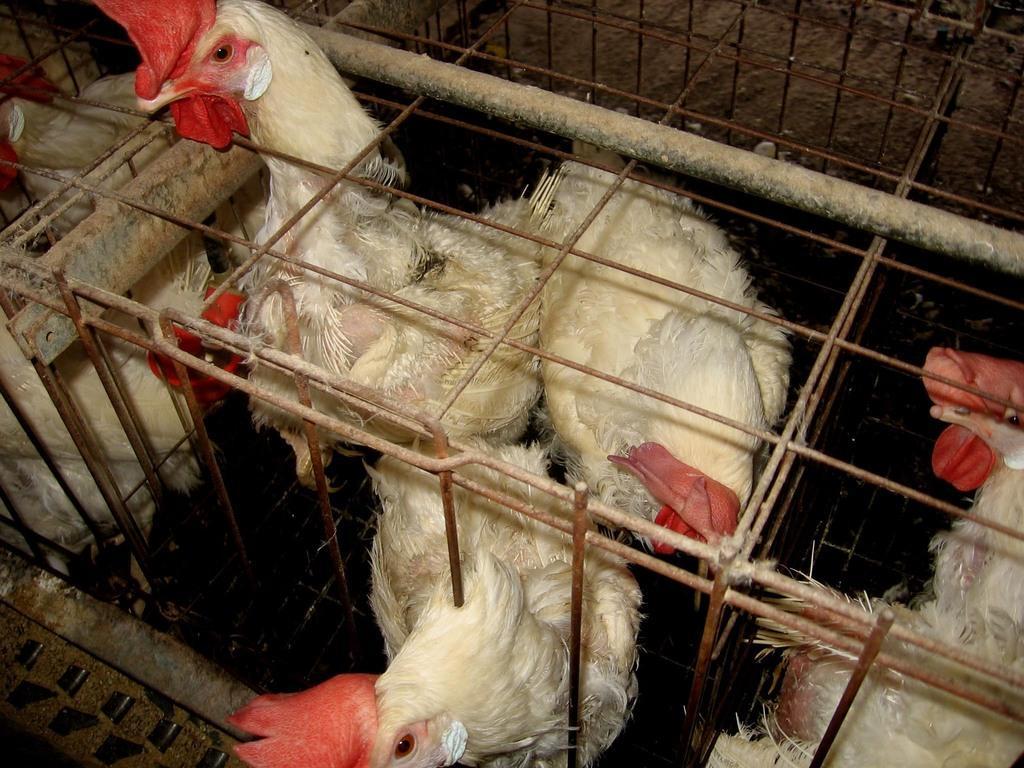Could you give a brief overview of what you see in this image? In this picture there are hens in the center of the image in a cage. 